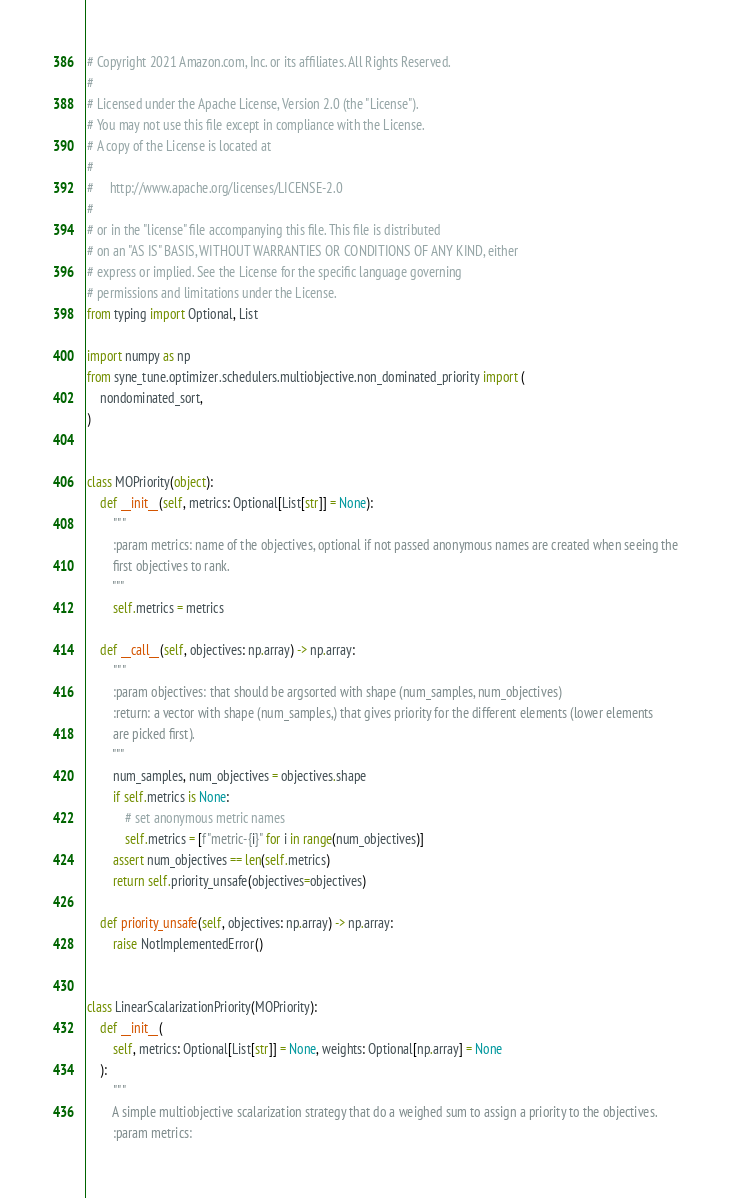<code> <loc_0><loc_0><loc_500><loc_500><_Python_># Copyright 2021 Amazon.com, Inc. or its affiliates. All Rights Reserved.
#
# Licensed under the Apache License, Version 2.0 (the "License").
# You may not use this file except in compliance with the License.
# A copy of the License is located at
#
#     http://www.apache.org/licenses/LICENSE-2.0
#
# or in the "license" file accompanying this file. This file is distributed
# on an "AS IS" BASIS, WITHOUT WARRANTIES OR CONDITIONS OF ANY KIND, either
# express or implied. See the License for the specific language governing
# permissions and limitations under the License.
from typing import Optional, List

import numpy as np
from syne_tune.optimizer.schedulers.multiobjective.non_dominated_priority import (
    nondominated_sort,
)


class MOPriority(object):
    def __init__(self, metrics: Optional[List[str]] = None):
        """
        :param metrics: name of the objectives, optional if not passed anonymous names are created when seeing the
        first objectives to rank.
        """
        self.metrics = metrics

    def __call__(self, objectives: np.array) -> np.array:
        """
        :param objectives: that should be argsorted with shape (num_samples, num_objectives)
        :return: a vector with shape (num_samples,) that gives priority for the different elements (lower elements
        are picked first).
        """
        num_samples, num_objectives = objectives.shape
        if self.metrics is None:
            # set anonymous metric names
            self.metrics = [f"metric-{i}" for i in range(num_objectives)]
        assert num_objectives == len(self.metrics)
        return self.priority_unsafe(objectives=objectives)

    def priority_unsafe(self, objectives: np.array) -> np.array:
        raise NotImplementedError()


class LinearScalarizationPriority(MOPriority):
    def __init__(
        self, metrics: Optional[List[str]] = None, weights: Optional[np.array] = None
    ):
        """
        A simple multiobjective scalarization strategy that do a weighed sum to assign a priority to the objectives.
        :param metrics:</code> 